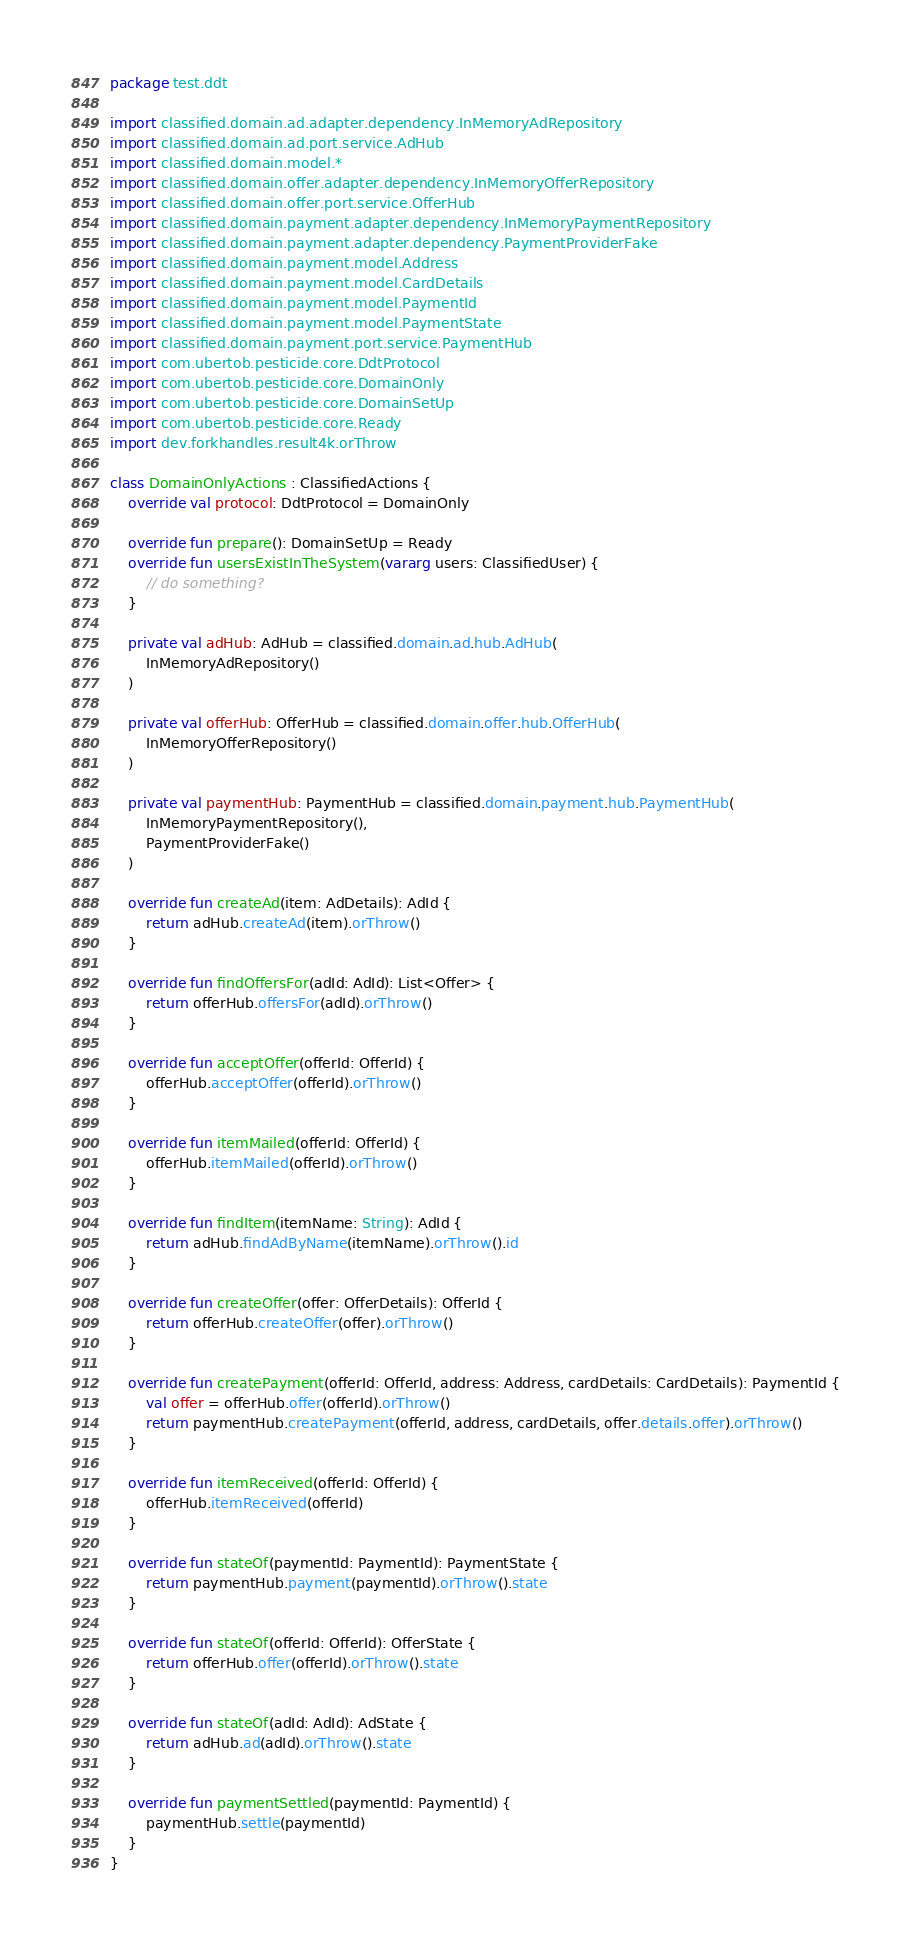<code> <loc_0><loc_0><loc_500><loc_500><_Kotlin_>package test.ddt

import classified.domain.ad.adapter.dependency.InMemoryAdRepository
import classified.domain.ad.port.service.AdHub
import classified.domain.model.*
import classified.domain.offer.adapter.dependency.InMemoryOfferRepository
import classified.domain.offer.port.service.OfferHub
import classified.domain.payment.adapter.dependency.InMemoryPaymentRepository
import classified.domain.payment.adapter.dependency.PaymentProviderFake
import classified.domain.payment.model.Address
import classified.domain.payment.model.CardDetails
import classified.domain.payment.model.PaymentId
import classified.domain.payment.model.PaymentState
import classified.domain.payment.port.service.PaymentHub
import com.ubertob.pesticide.core.DdtProtocol
import com.ubertob.pesticide.core.DomainOnly
import com.ubertob.pesticide.core.DomainSetUp
import com.ubertob.pesticide.core.Ready
import dev.forkhandles.result4k.orThrow

class DomainOnlyActions : ClassifiedActions {
    override val protocol: DdtProtocol = DomainOnly

    override fun prepare(): DomainSetUp = Ready
    override fun usersExistInTheSystem(vararg users: ClassifiedUser) {
        // do something?
    }

    private val adHub: AdHub = classified.domain.ad.hub.AdHub(
        InMemoryAdRepository()
    )

    private val offerHub: OfferHub = classified.domain.offer.hub.OfferHub(
        InMemoryOfferRepository()
    )

    private val paymentHub: PaymentHub = classified.domain.payment.hub.PaymentHub(
        InMemoryPaymentRepository(),
        PaymentProviderFake()
    )

    override fun createAd(item: AdDetails): AdId {
        return adHub.createAd(item).orThrow()
    }

    override fun findOffersFor(adId: AdId): List<Offer> {
        return offerHub.offersFor(adId).orThrow()
    }

    override fun acceptOffer(offerId: OfferId) {
        offerHub.acceptOffer(offerId).orThrow()
    }

    override fun itemMailed(offerId: OfferId) {
        offerHub.itemMailed(offerId).orThrow()
    }

    override fun findItem(itemName: String): AdId {
        return adHub.findAdByName(itemName).orThrow().id
    }

    override fun createOffer(offer: OfferDetails): OfferId {
        return offerHub.createOffer(offer).orThrow()
    }

    override fun createPayment(offerId: OfferId, address: Address, cardDetails: CardDetails): PaymentId {
        val offer = offerHub.offer(offerId).orThrow()
        return paymentHub.createPayment(offerId, address, cardDetails, offer.details.offer).orThrow()
    }

    override fun itemReceived(offerId: OfferId) {
        offerHub.itemReceived(offerId)
    }

    override fun stateOf(paymentId: PaymentId): PaymentState {
        return paymentHub.payment(paymentId).orThrow().state
    }

    override fun stateOf(offerId: OfferId): OfferState {
        return offerHub.offer(offerId).orThrow().state
    }

    override fun stateOf(adId: AdId): AdState {
        return adHub.ad(adId).orThrow().state
    }

    override fun paymentSettled(paymentId: PaymentId) {
        paymentHub.settle(paymentId)
    }
}</code> 